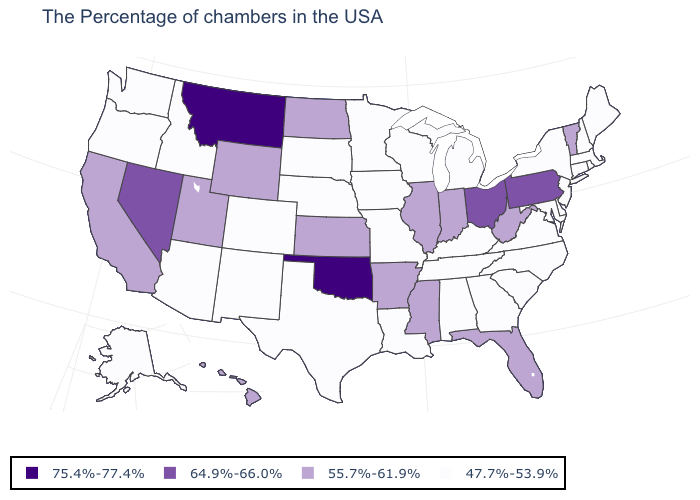Name the states that have a value in the range 47.7%-53.9%?
Quick response, please. Maine, Massachusetts, Rhode Island, New Hampshire, Connecticut, New York, New Jersey, Delaware, Maryland, Virginia, North Carolina, South Carolina, Georgia, Michigan, Kentucky, Alabama, Tennessee, Wisconsin, Louisiana, Missouri, Minnesota, Iowa, Nebraska, Texas, South Dakota, Colorado, New Mexico, Arizona, Idaho, Washington, Oregon, Alaska. Is the legend a continuous bar?
Write a very short answer. No. What is the lowest value in the MidWest?
Be succinct. 47.7%-53.9%. What is the value of Arkansas?
Be succinct. 55.7%-61.9%. Does Ohio have a higher value than Montana?
Give a very brief answer. No. Does Oklahoma have the highest value in the USA?
Give a very brief answer. Yes. Which states hav the highest value in the West?
Quick response, please. Montana. Does Oregon have the lowest value in the West?
Be succinct. Yes. What is the value of New Jersey?
Be succinct. 47.7%-53.9%. What is the value of Montana?
Be succinct. 75.4%-77.4%. Among the states that border Georgia , does Alabama have the lowest value?
Answer briefly. Yes. How many symbols are there in the legend?
Keep it brief. 4. Does Kentucky have the lowest value in the South?
Concise answer only. Yes. Name the states that have a value in the range 75.4%-77.4%?
Keep it brief. Oklahoma, Montana. Does Wyoming have the lowest value in the West?
Concise answer only. No. 